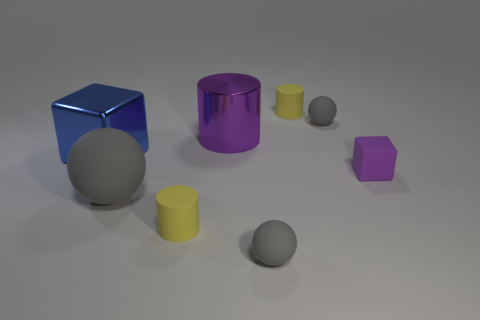What size is the rubber block that is the same color as the metallic cylinder?
Your answer should be very brief. Small. Do the tiny cube and the large shiny cube have the same color?
Provide a succinct answer. No. There is a matte object that is the same color as the shiny cylinder; what is its shape?
Ensure brevity in your answer.  Cube. There is a shiny object that is the same shape as the purple matte object; what color is it?
Your answer should be very brief. Blue. What number of objects are either large brown metallic cylinders or shiny cylinders?
Your answer should be very brief. 1. There is a gray thing that is behind the big blue metallic block; is its shape the same as the purple object right of the large metallic cylinder?
Keep it short and to the point. No. There is a yellow object that is in front of the tiny cube; what shape is it?
Keep it short and to the point. Cylinder. Are there an equal number of large objects that are in front of the big ball and tiny purple matte objects that are behind the blue metal cube?
Give a very brief answer. Yes. What number of objects are either small yellow rubber things or small matte objects that are behind the big blue thing?
Provide a short and direct response. 3. What shape is the gray rubber thing that is to the right of the purple metal cylinder and in front of the small purple block?
Ensure brevity in your answer.  Sphere. 